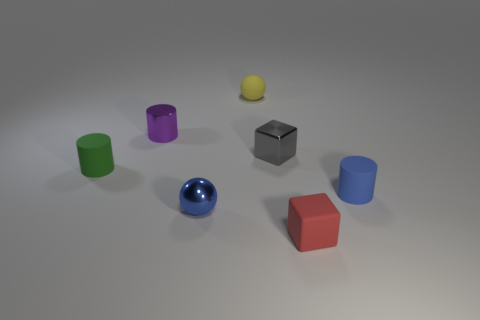Subtract all spheres. How many objects are left? 5 Add 3 blue matte objects. How many objects exist? 10 Subtract 0 yellow blocks. How many objects are left? 7 Subtract 2 cylinders. How many cylinders are left? 1 Subtract all red cylinders. Subtract all purple blocks. How many cylinders are left? 3 Subtract all brown cylinders. How many blue spheres are left? 1 Subtract all tiny shiny cylinders. Subtract all small purple objects. How many objects are left? 5 Add 5 purple metallic things. How many purple metallic things are left? 6 Add 2 green rubber cylinders. How many green rubber cylinders exist? 3 Subtract all yellow spheres. How many spheres are left? 1 